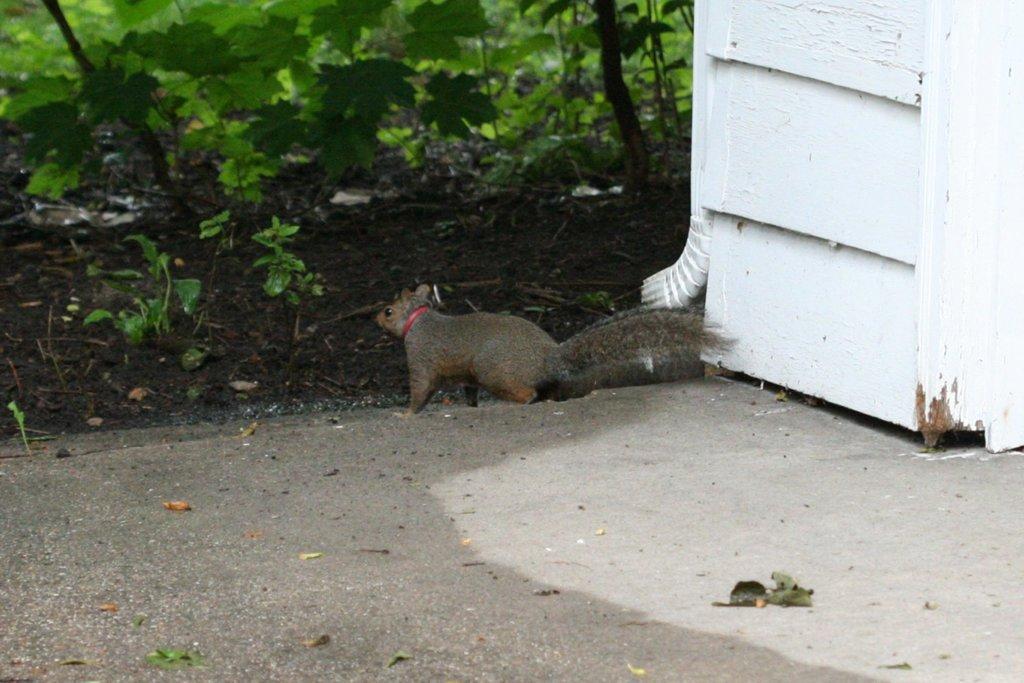How would you summarize this image in a sentence or two? In this image I can see a squirrel which is in brown color, in front I can see few plants in green color and I can also see a white color object. 